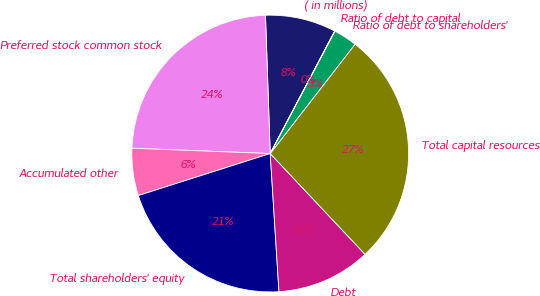Convert chart. <chart><loc_0><loc_0><loc_500><loc_500><pie_chart><fcel>( in millions)<fcel>Preferred stock common stock<fcel>Accumulated other<fcel>Total shareholders' equity<fcel>Debt<fcel>Total capital resources<fcel>Ratio of debt to shareholders'<fcel>Ratio of debt to capital<nl><fcel>8.26%<fcel>23.84%<fcel>5.52%<fcel>21.1%<fcel>11.01%<fcel>27.48%<fcel>2.77%<fcel>0.02%<nl></chart> 